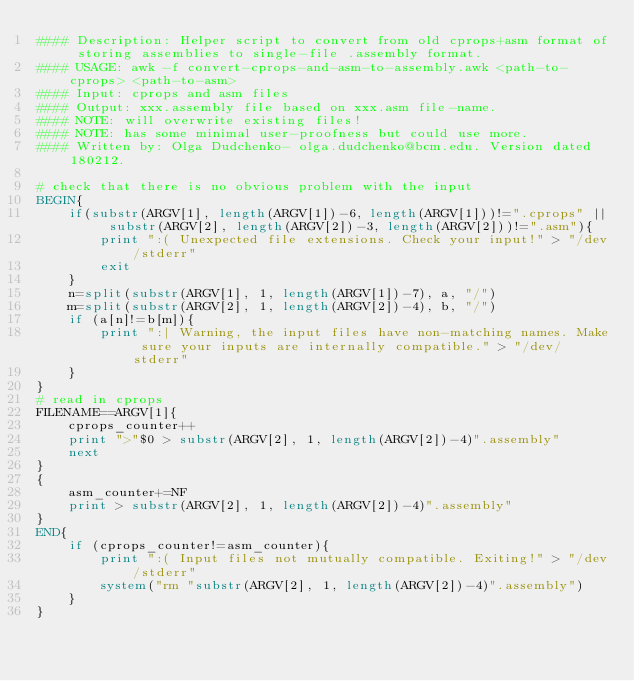Convert code to text. <code><loc_0><loc_0><loc_500><loc_500><_Awk_>#### Description: Helper script to convert from old cprops+asm format of storing assemblies to single-file .assembly format.
#### USAGE: awk -f convert-cprops-and-asm-to-assembly.awk <path-to-cprops> <path-to-asm>
#### Input: cprops and asm files
#### Output: xxx.assembly file based on xxx.asm file-name.
#### NOTE: will overwrite existing files!
#### NOTE: has some minimal user-proofness but could use more.
#### Written by: Olga Dudchenko- olga.dudchenko@bcm.edu. Version dated 180212.

# check that there is no obvious problem with the input
BEGIN{	
	if(substr(ARGV[1], length(ARGV[1])-6, length(ARGV[1]))!=".cprops" || substr(ARGV[2], length(ARGV[2])-3, length(ARGV[2]))!=".asm"){
		print ":( Unexpected file extensions. Check your input!" > "/dev/stderr"
		exit
	}
	n=split(substr(ARGV[1], 1, length(ARGV[1])-7), a, "/")
	m=split(substr(ARGV[2], 1, length(ARGV[2])-4), b, "/")
	if (a[n]!=b[m]){
		print ":| Warning, the input files have non-matching names. Make sure your inputs are internally compatible." > "/dev/stderr"
	}
}
# read in cprops
FILENAME==ARGV[1]{
	cprops_counter++
	print ">"$0 > substr(ARGV[2], 1, length(ARGV[2])-4)".assembly"
	next
}
{
	asm_counter+=NF
	print > substr(ARGV[2], 1, length(ARGV[2])-4)".assembly"
}
END{
	if (cprops_counter!=asm_counter){
		print ":( Input files not mutually compatible. Exiting!" > "/dev/stderr"
		system("rm "substr(ARGV[2], 1, length(ARGV[2])-4)".assembly")
	}
}</code> 